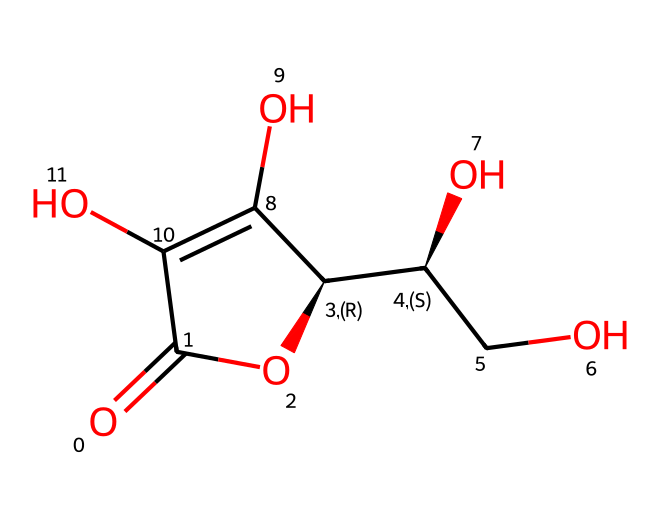What is the molecular formula of vitamin C based on the structure? The SMILES representation given can be translated to the molecular formula by counting the different atoms visible in the structure. By analyzing the SMILES, we can find that there are six carbon (C) atoms, eight hydrogen (H) atoms, and six oxygen (O) atoms, resulting in the molecular formula C6H8O6.
Answer: C6H8O6 How many oxygen atoms are present in this molecule? A quick examination of the SMILES representation indicates that there are six oxygen (O) atoms as part of the structure. Counting directly from the structure allows us to arrive at the correct number.
Answer: 6 What type of compound is vitamin C? This molecule fits the definition of an organic compound due to the presence of carbon atoms in its structure and it specifically classifies as a carbohydrate because of its ring structure containing hydroxyl groups. Thus, it is classified as an organic carbohydrate.
Answer: carbohydrate Which functional groups can be identified in vitamin C? By examining the chemical structure depicted in the SMILES representation, we can recognize the presence of hydroxyl (-OH) groups and a lactone (cyclic ester) functional group, which contribute to its properties as a vitamin. This analysis identifies the key functional groups.
Answer: hydroxyl, lactone What structural feature leads to the antioxidant property of vitamin C? The molecule features several hydroxyl groups, which are known to donate hydrogen atoms or electrons, making it a good antioxidant. The presence of such functional groups aids vitamin C in neutralizing free radicals. This recognition of structural features shows why it acts as an antioxidant.
Answer: hydroxyl groups How does the double bond in the structure affect vitamin C's stability? The presence of a double bond within the cyclic structure introduces an element of potential reactivity, as double bonds can be sites for chemical reactions. However, in the context of vitamin C, this bond is part of a stable cyclic structure that helps maintain its integrity under normal conditions, indicating a balance of stability and reactivity.
Answer: cyclic structure 